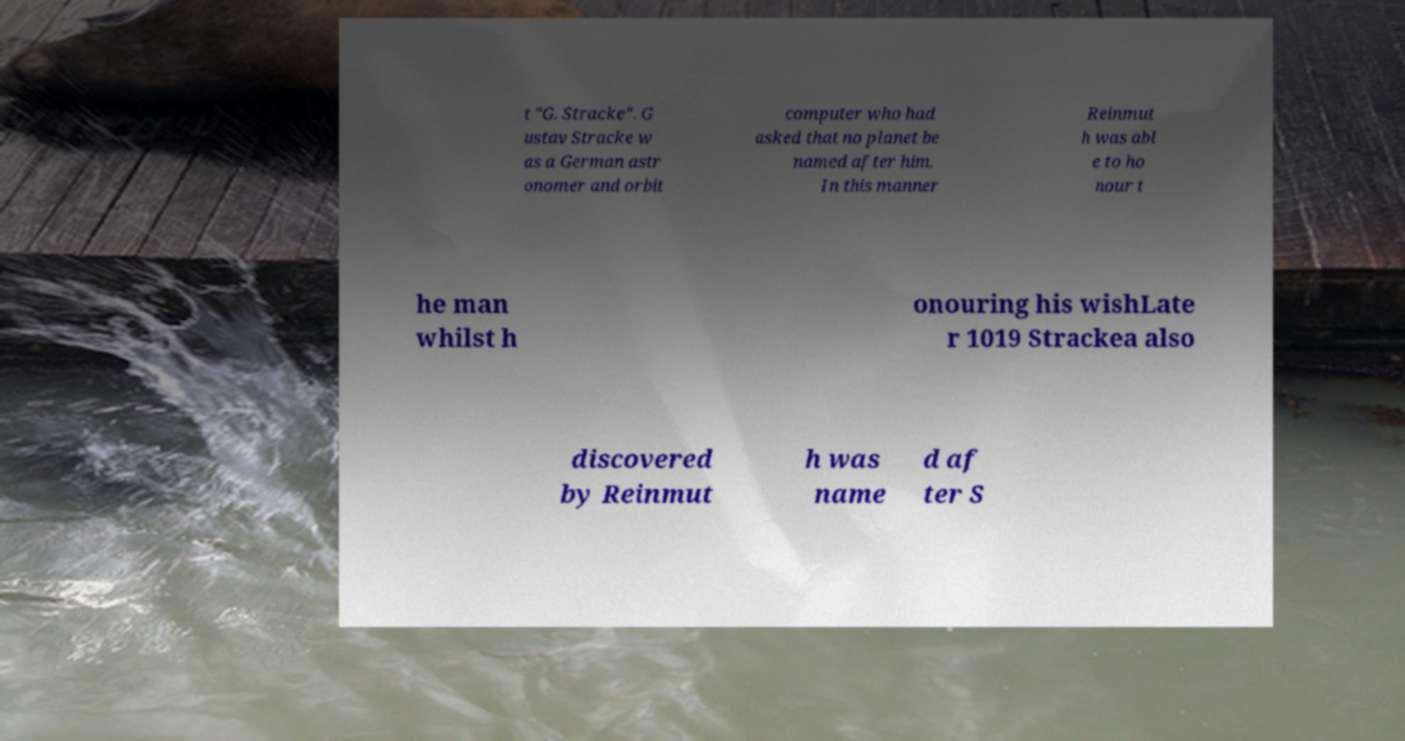There's text embedded in this image that I need extracted. Can you transcribe it verbatim? t "G. Stracke". G ustav Stracke w as a German astr onomer and orbit computer who had asked that no planet be named after him. In this manner Reinmut h was abl e to ho nour t he man whilst h onouring his wishLate r 1019 Strackea also discovered by Reinmut h was name d af ter S 